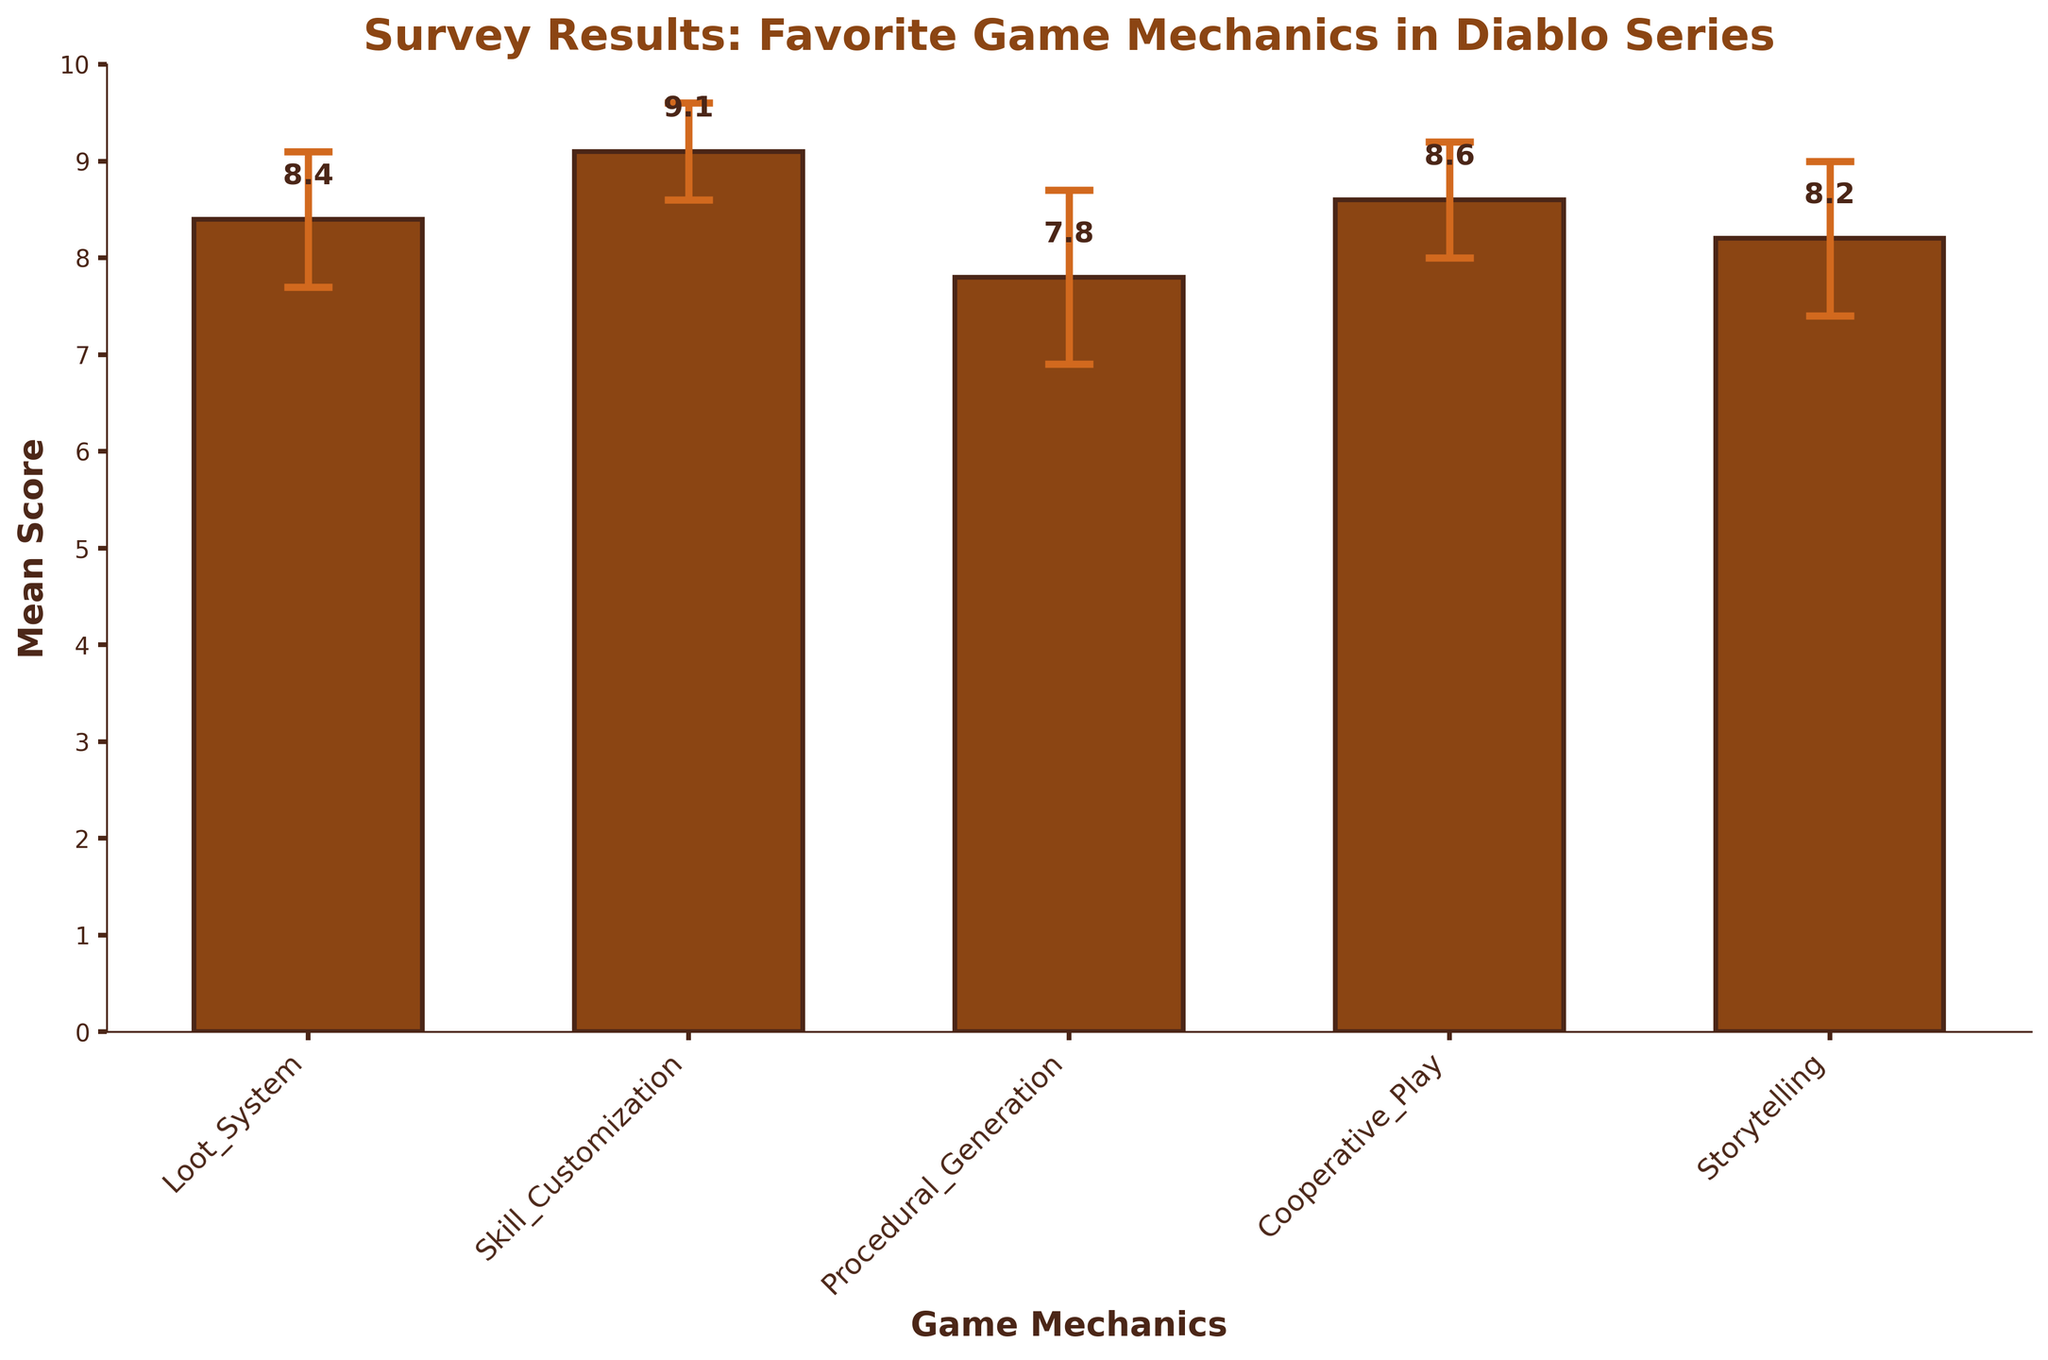what's the mean score of the Skill Customization mechanic? The bar corresponding to Skill Customization has a mean score label of 9.1 positioned above it.
Answer: 9.1 what color are the bars in the chart? The bars in the chart are brown. This is visually identifiable by their color in the figure.
Answer: brown what is the title of the figure? The title is located at the top center of the figure and reads "Survey Results: Favorite Game Mechanics in Diablo Series."
Answer: Survey Results: Favorite Game Mechanics in Diablo Series how many game mechanics are represented in the figure? The x-axis has labels for each game mechanic, counting them gives five mechanics.
Answer: 5 which game mechanic has the highest mean score? By comparing the heights of all the bars, Skill Customization has the highest mean score of 9.1.
Answer: Skill Customization which game mechanic has the lowest mean score? Procedural Generation has the lowest mean score of 7.8, as shown by the shortest bar.
Answer: Procedural Generation what's the difference in mean scores between Loot System and Cooperative Play? The mean score for Loot System is 8.4 and for Cooperative Play is 8.6. The difference is calculated as 8.6 - 8.4 = 0.2.
Answer: 0.2 how does the variability in scores for Procedural Generation compare to Skill Customization? Procedural Generation has a standard deviation of 0.9, whereas Skill Customization has a standard deviation of 0.5. Procedural Generation has higher variability.
Answer: Procedural Generation has higher variability which game mechanic has an error bar that indicates the smallest response variability? The smallest standard deviation is 0.5 for Skill Customization, indicating it has the smallest response variability.
Answer: Skill Customization are the mean scores for Storytelling and Loot System relatively close? The mean score for Storytelling is 8.2 and for Loot System is 8.4. The difference is 8.4 - 8.2 = 0.2, indicating they are relatively close.
Answer: yes 